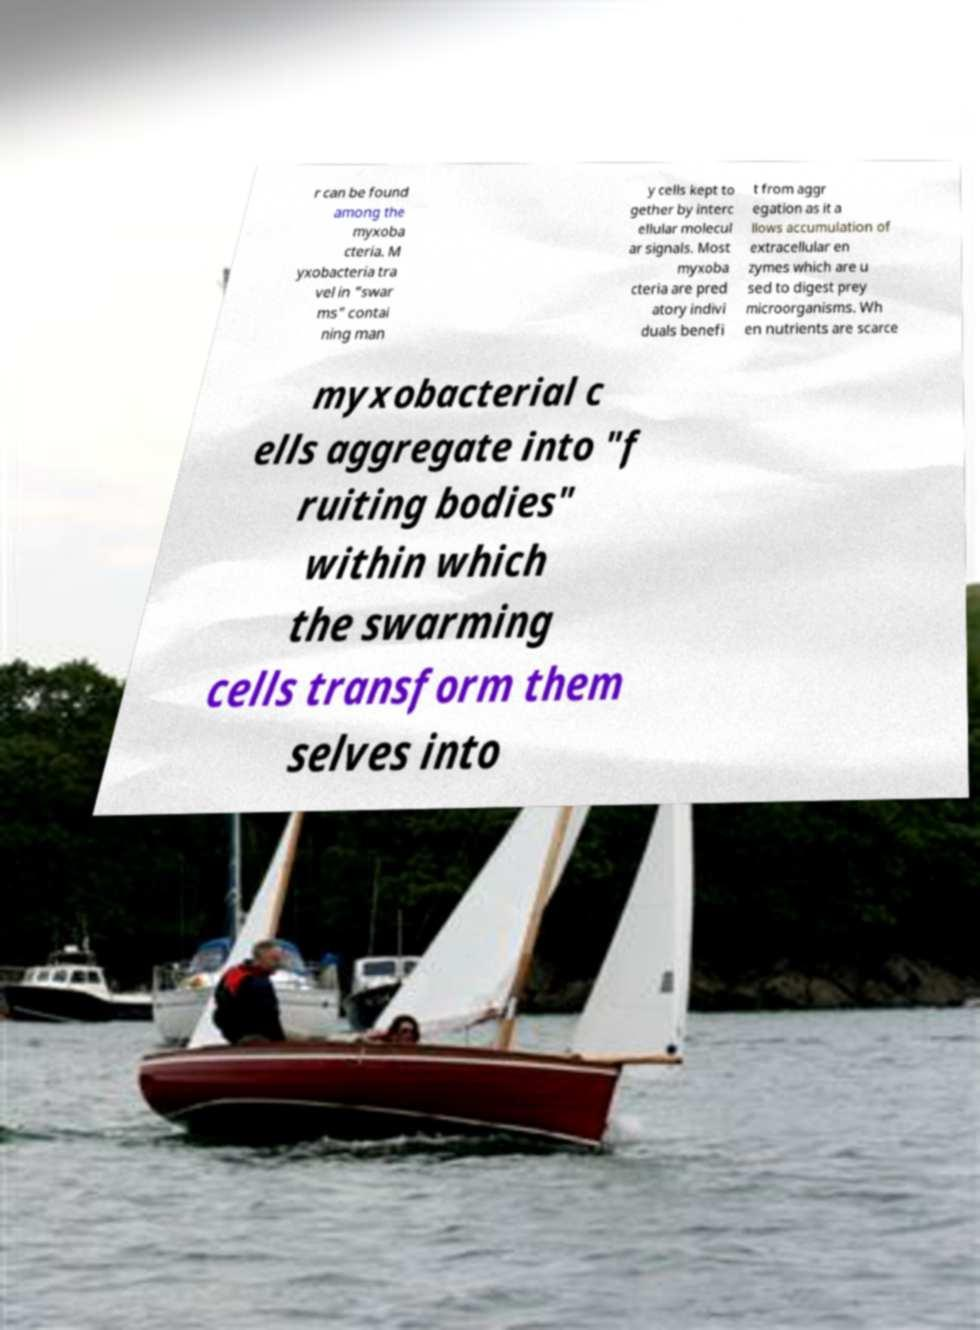For documentation purposes, I need the text within this image transcribed. Could you provide that? r can be found among the myxoba cteria. M yxobacteria tra vel in "swar ms" contai ning man y cells kept to gether by interc ellular molecul ar signals. Most myxoba cteria are pred atory indivi duals benefi t from aggr egation as it a llows accumulation of extracellular en zymes which are u sed to digest prey microorganisms. Wh en nutrients are scarce myxobacterial c ells aggregate into "f ruiting bodies" within which the swarming cells transform them selves into 